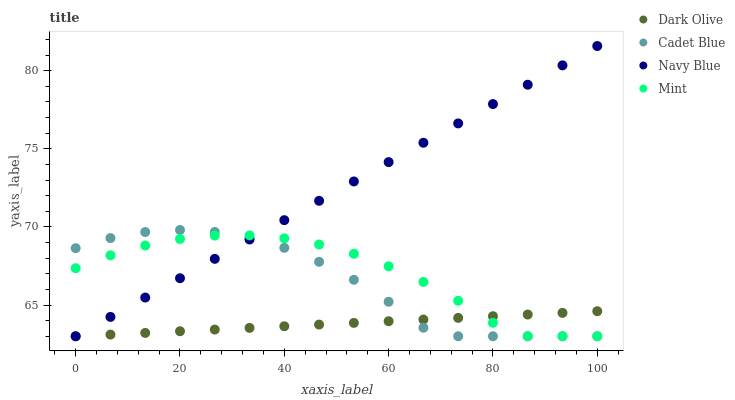Does Dark Olive have the minimum area under the curve?
Answer yes or no. Yes. Does Navy Blue have the maximum area under the curve?
Answer yes or no. Yes. Does Navy Blue have the minimum area under the curve?
Answer yes or no. No. Does Dark Olive have the maximum area under the curve?
Answer yes or no. No. Is Navy Blue the smoothest?
Answer yes or no. Yes. Is Cadet Blue the roughest?
Answer yes or no. Yes. Is Dark Olive the smoothest?
Answer yes or no. No. Is Dark Olive the roughest?
Answer yes or no. No. Does Cadet Blue have the lowest value?
Answer yes or no. Yes. Does Navy Blue have the highest value?
Answer yes or no. Yes. Does Dark Olive have the highest value?
Answer yes or no. No. Does Navy Blue intersect Cadet Blue?
Answer yes or no. Yes. Is Navy Blue less than Cadet Blue?
Answer yes or no. No. Is Navy Blue greater than Cadet Blue?
Answer yes or no. No. 